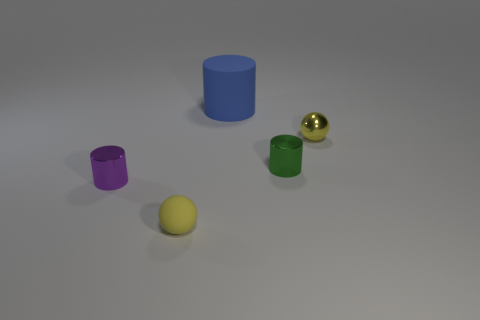Subtract all green cylinders. Subtract all cyan balls. How many cylinders are left? 2 Add 2 tiny yellow metallic things. How many objects exist? 7 Subtract all cylinders. How many objects are left? 2 Subtract 0 blue blocks. How many objects are left? 5 Subtract all big gray matte things. Subtract all green things. How many objects are left? 4 Add 2 yellow rubber spheres. How many yellow rubber spheres are left? 3 Add 4 blue objects. How many blue objects exist? 5 